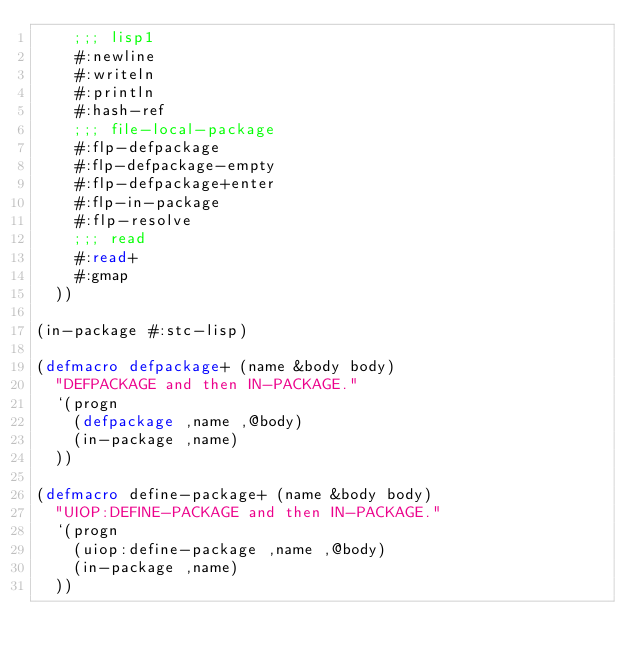<code> <loc_0><loc_0><loc_500><loc_500><_Lisp_>    ;;; lisp1
    #:newline
    #:writeln
    #:println
    #:hash-ref
    ;;; file-local-package
    #:flp-defpackage
    #:flp-defpackage-empty
    #:flp-defpackage+enter
    #:flp-in-package
    #:flp-resolve
    ;;; read
    #:read+
    #:gmap
  ))

(in-package #:stc-lisp)

(defmacro defpackage+ (name &body body)
  "DEFPACKAGE and then IN-PACKAGE."
  `(progn
    (defpackage ,name ,@body)
    (in-package ,name)
  ))

(defmacro define-package+ (name &body body)
  "UIOP:DEFINE-PACKAGE and then IN-PACKAGE."
  `(progn
    (uiop:define-package ,name ,@body)
    (in-package ,name)
  ))
</code> 